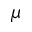<formula> <loc_0><loc_0><loc_500><loc_500>\mu</formula> 